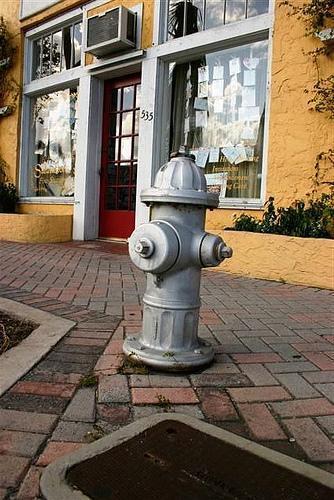How many hydrants in the photo?
Give a very brief answer. 1. How many ski poles are there?
Give a very brief answer. 0. 